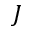Convert formula to latex. <formula><loc_0><loc_0><loc_500><loc_500>J</formula> 